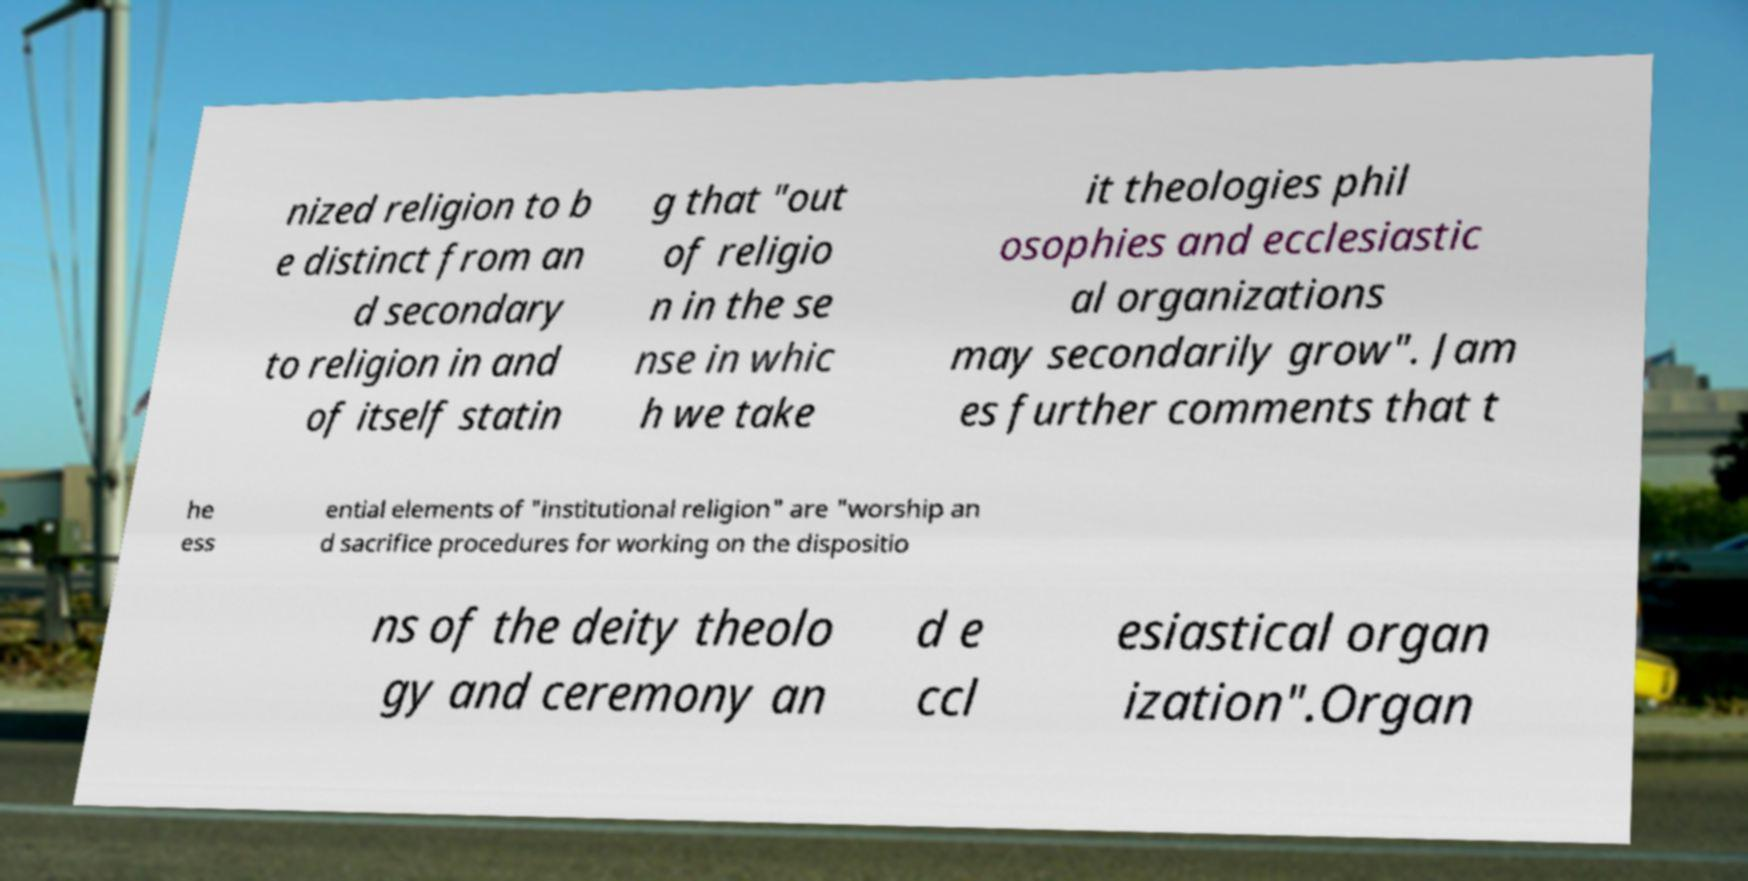There's text embedded in this image that I need extracted. Can you transcribe it verbatim? nized religion to b e distinct from an d secondary to religion in and of itself statin g that "out of religio n in the se nse in whic h we take it theologies phil osophies and ecclesiastic al organizations may secondarily grow". Jam es further comments that t he ess ential elements of "institutional religion" are "worship an d sacrifice procedures for working on the dispositio ns of the deity theolo gy and ceremony an d e ccl esiastical organ ization".Organ 